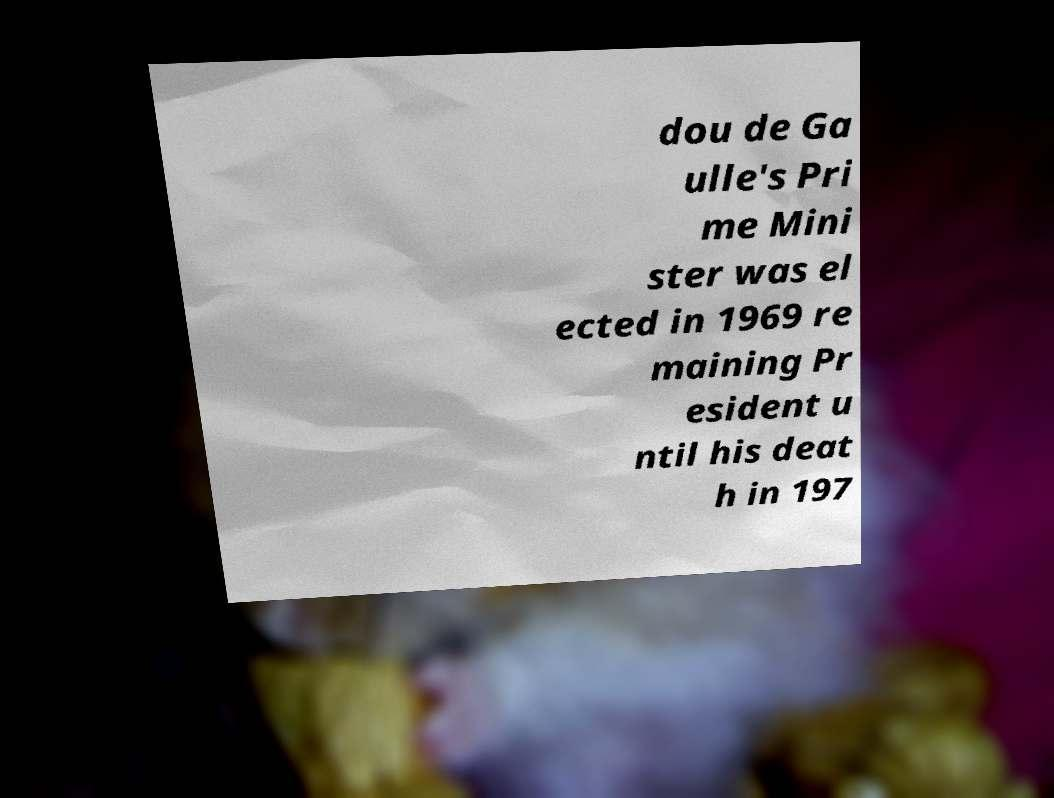Can you read and provide the text displayed in the image?This photo seems to have some interesting text. Can you extract and type it out for me? dou de Ga ulle's Pri me Mini ster was el ected in 1969 re maining Pr esident u ntil his deat h in 197 